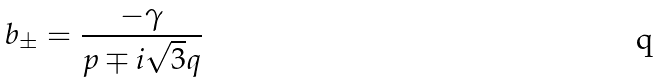<formula> <loc_0><loc_0><loc_500><loc_500>b _ { \pm } = \frac { - \gamma } { p \mp i \sqrt { 3 } q }</formula> 